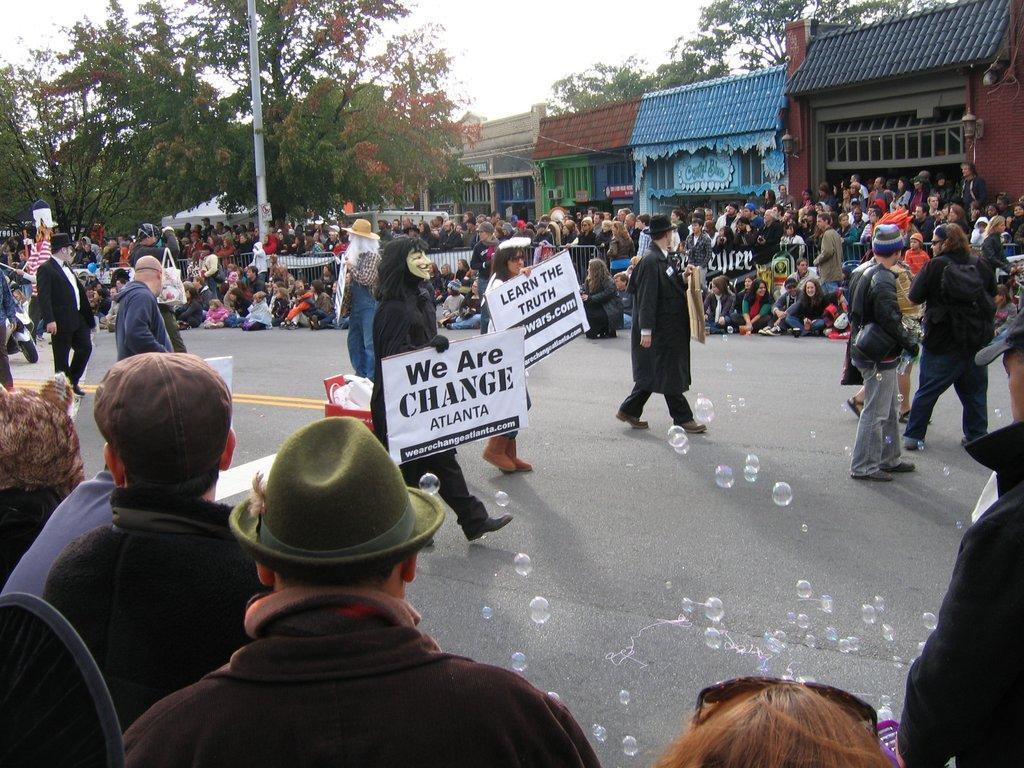Can you describe this image briefly? In this picture we can see there are groups of people, some people are holding the boards and some people are in the fancy dresses. Behind the people, there are trees, a pole, buildings and the sky. At the bottom of the image, there are bubbles. 